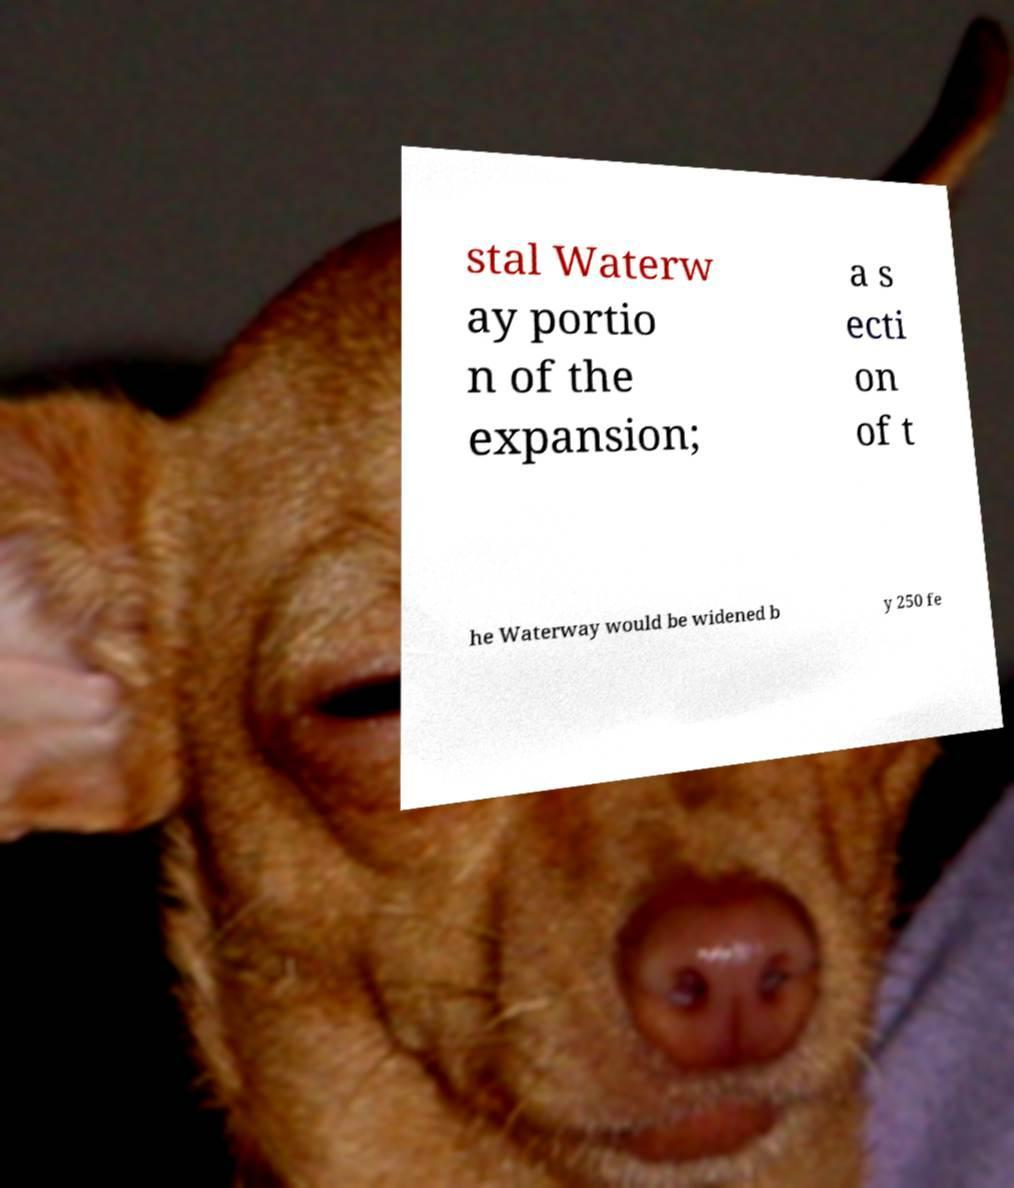For documentation purposes, I need the text within this image transcribed. Could you provide that? stal Waterw ay portio n of the expansion; a s ecti on of t he Waterway would be widened b y 250 fe 